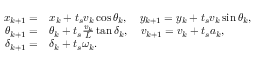Convert formula to latex. <formula><loc_0><loc_0><loc_500><loc_500>\begin{array} { r } { \begin{array} { r l } { x _ { k + 1 } = } & { x _ { k } + t _ { s } v _ { k } \cos { \theta _ { k } } , \quad y _ { k + 1 } = y _ { k } + t _ { s } v _ { k } \sin { \theta _ { k } } , } \\ { \theta _ { k + 1 } = } & { \theta _ { k } + t _ { s } \frac { v _ { k } } { L } \tan { \delta _ { k } } , \quad v _ { k + 1 } = v _ { k } + t _ { s } a _ { k } , } \\ { \delta _ { k + 1 } = } & { \delta _ { k } + t _ { s } \omega _ { k } . } \end{array} } \end{array}</formula> 